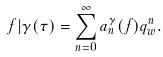<formula> <loc_0><loc_0><loc_500><loc_500>f | \gamma ( \tau ) = \sum _ { n = 0 } ^ { \infty } a _ { n } ^ { \gamma } ( f ) q _ { w } ^ { n } .</formula> 